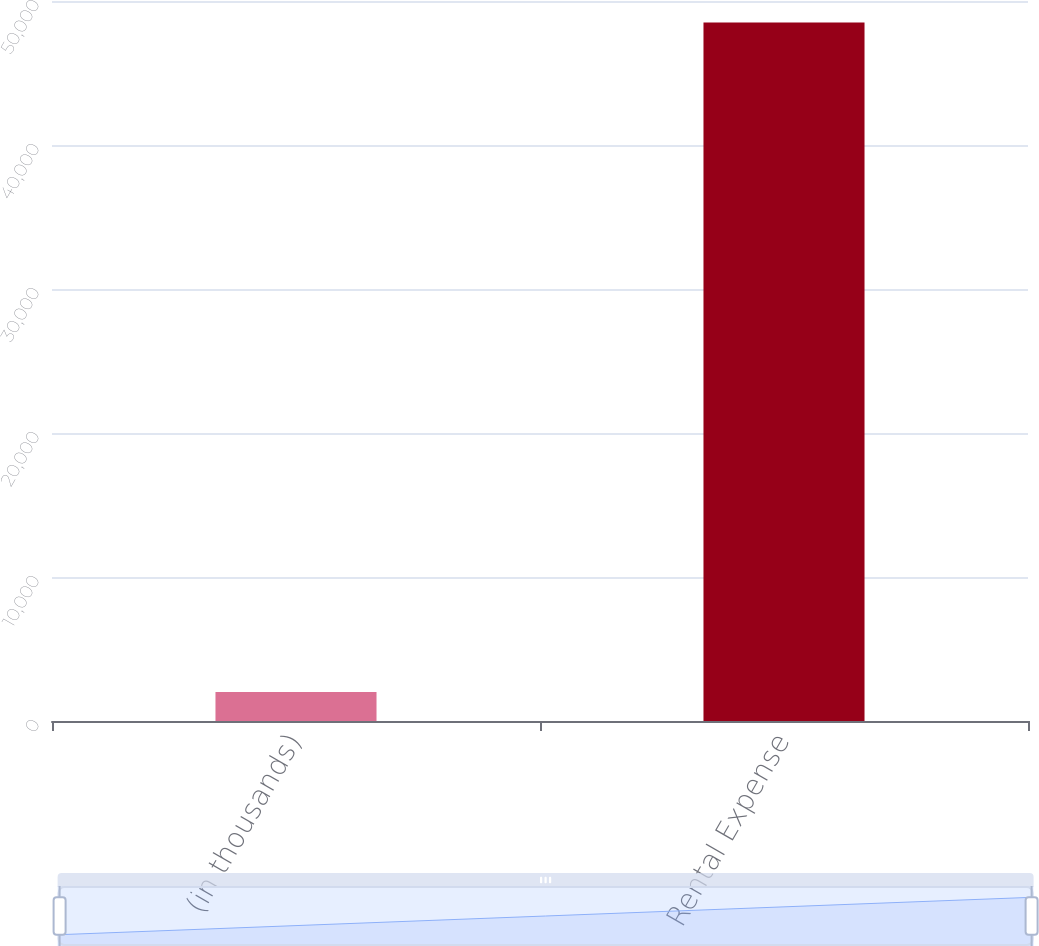Convert chart. <chart><loc_0><loc_0><loc_500><loc_500><bar_chart><fcel>(in thousands)<fcel>Rental Expense<nl><fcel>2012<fcel>48511<nl></chart> 